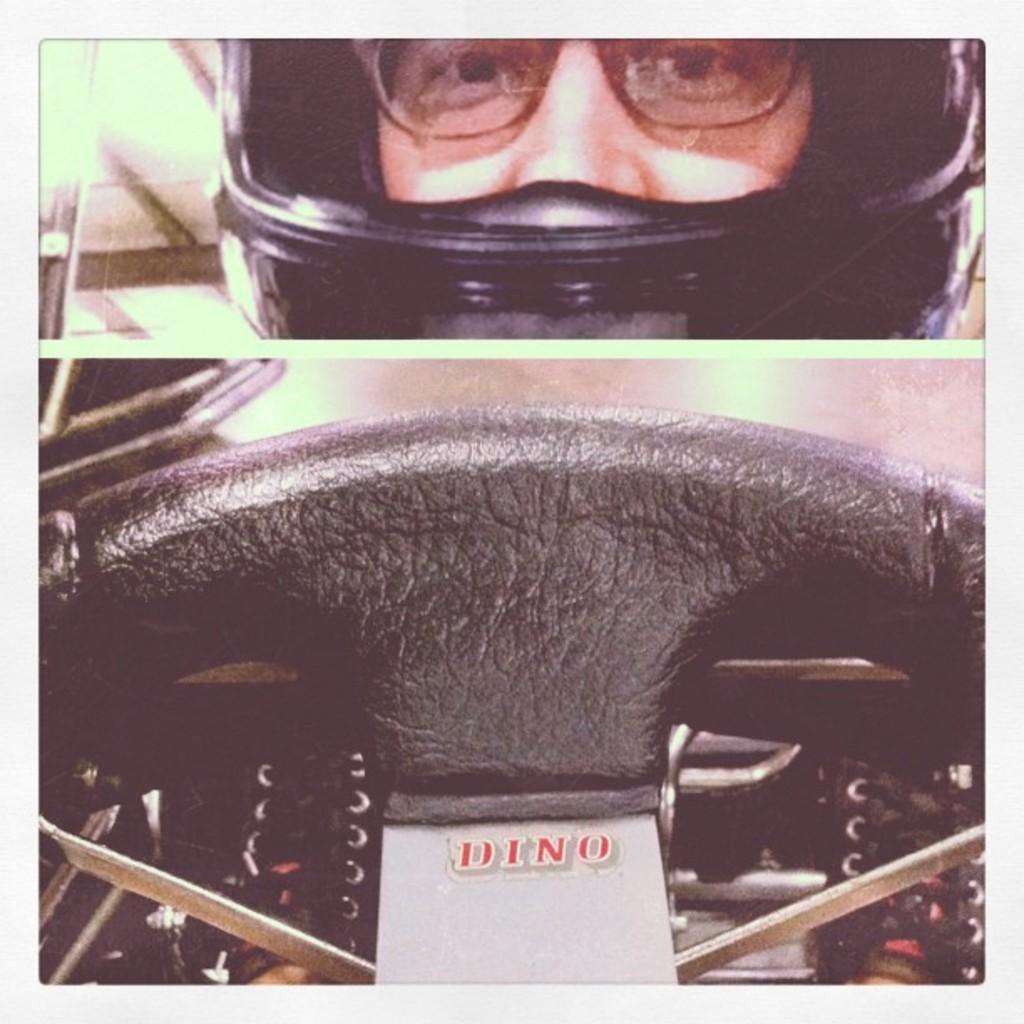In one or two sentences, can you explain what this image depicts? In this image I can see the collage picture in which I can see the steering which is black in color and a person wearing black colored helmet and spectacles. 